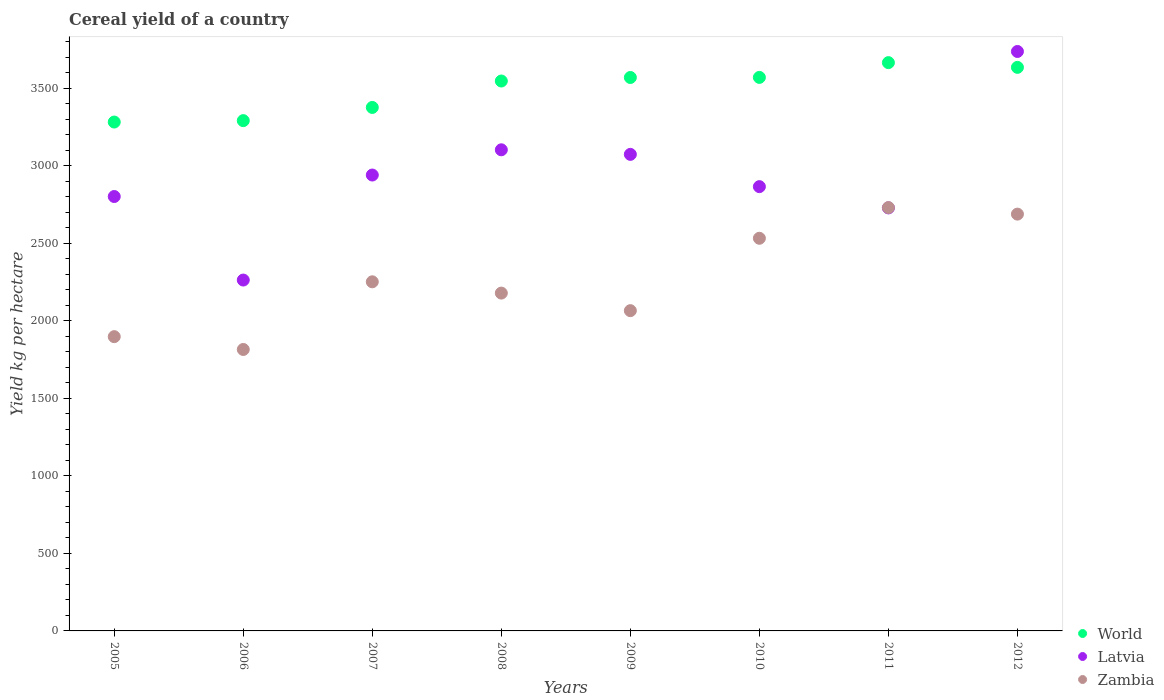How many different coloured dotlines are there?
Make the answer very short. 3. What is the total cereal yield in Latvia in 2010?
Give a very brief answer. 2866.68. Across all years, what is the maximum total cereal yield in Latvia?
Make the answer very short. 3738.81. Across all years, what is the minimum total cereal yield in Latvia?
Make the answer very short. 2263.97. In which year was the total cereal yield in World minimum?
Your answer should be very brief. 2005. What is the total total cereal yield in World in the graph?
Ensure brevity in your answer.  2.79e+04. What is the difference between the total cereal yield in Zambia in 2005 and that in 2009?
Offer a very short reply. -167.71. What is the difference between the total cereal yield in Latvia in 2008 and the total cereal yield in Zambia in 2010?
Your response must be concise. 570.87. What is the average total cereal yield in World per year?
Offer a very short reply. 3493.44. In the year 2010, what is the difference between the total cereal yield in World and total cereal yield in Latvia?
Your answer should be very brief. 704.85. In how many years, is the total cereal yield in World greater than 1500 kg per hectare?
Ensure brevity in your answer.  8. What is the ratio of the total cereal yield in World in 2008 to that in 2009?
Your answer should be very brief. 0.99. What is the difference between the highest and the second highest total cereal yield in Latvia?
Ensure brevity in your answer.  634.43. What is the difference between the highest and the lowest total cereal yield in Latvia?
Give a very brief answer. 1474.84. Does the total cereal yield in Latvia monotonically increase over the years?
Keep it short and to the point. No. Is the total cereal yield in Latvia strictly greater than the total cereal yield in World over the years?
Ensure brevity in your answer.  No. What is the difference between two consecutive major ticks on the Y-axis?
Offer a terse response. 500. Are the values on the major ticks of Y-axis written in scientific E-notation?
Give a very brief answer. No. Does the graph contain any zero values?
Your answer should be very brief. No. Where does the legend appear in the graph?
Give a very brief answer. Bottom right. How are the legend labels stacked?
Offer a terse response. Vertical. What is the title of the graph?
Offer a very short reply. Cereal yield of a country. What is the label or title of the X-axis?
Offer a very short reply. Years. What is the label or title of the Y-axis?
Your answer should be compact. Yield kg per hectare. What is the Yield kg per hectare in World in 2005?
Provide a succinct answer. 3283.52. What is the Yield kg per hectare of Latvia in 2005?
Your answer should be very brief. 2802.94. What is the Yield kg per hectare in Zambia in 2005?
Give a very brief answer. 1898.74. What is the Yield kg per hectare in World in 2006?
Make the answer very short. 3292.55. What is the Yield kg per hectare of Latvia in 2006?
Your answer should be very brief. 2263.97. What is the Yield kg per hectare in Zambia in 2006?
Offer a very short reply. 1815.98. What is the Yield kg per hectare of World in 2007?
Provide a succinct answer. 3377.69. What is the Yield kg per hectare of Latvia in 2007?
Offer a terse response. 2941.56. What is the Yield kg per hectare of Zambia in 2007?
Make the answer very short. 2252.64. What is the Yield kg per hectare in World in 2008?
Give a very brief answer. 3548.21. What is the Yield kg per hectare in Latvia in 2008?
Make the answer very short. 3104.37. What is the Yield kg per hectare in Zambia in 2008?
Make the answer very short. 2179.78. What is the Yield kg per hectare in World in 2009?
Offer a very short reply. 3570.96. What is the Yield kg per hectare in Latvia in 2009?
Provide a short and direct response. 3074.88. What is the Yield kg per hectare of Zambia in 2009?
Ensure brevity in your answer.  2066.44. What is the Yield kg per hectare in World in 2010?
Provide a short and direct response. 3571.53. What is the Yield kg per hectare in Latvia in 2010?
Provide a short and direct response. 2866.68. What is the Yield kg per hectare of Zambia in 2010?
Ensure brevity in your answer.  2533.5. What is the Yield kg per hectare in World in 2011?
Give a very brief answer. 3666.79. What is the Yield kg per hectare in Latvia in 2011?
Your answer should be compact. 2729.47. What is the Yield kg per hectare of Zambia in 2011?
Provide a short and direct response. 2731.43. What is the Yield kg per hectare in World in 2012?
Ensure brevity in your answer.  3636.3. What is the Yield kg per hectare of Latvia in 2012?
Ensure brevity in your answer.  3738.81. What is the Yield kg per hectare in Zambia in 2012?
Offer a very short reply. 2689.32. Across all years, what is the maximum Yield kg per hectare in World?
Your answer should be compact. 3666.79. Across all years, what is the maximum Yield kg per hectare in Latvia?
Offer a very short reply. 3738.81. Across all years, what is the maximum Yield kg per hectare in Zambia?
Make the answer very short. 2731.43. Across all years, what is the minimum Yield kg per hectare of World?
Ensure brevity in your answer.  3283.52. Across all years, what is the minimum Yield kg per hectare of Latvia?
Ensure brevity in your answer.  2263.97. Across all years, what is the minimum Yield kg per hectare in Zambia?
Ensure brevity in your answer.  1815.98. What is the total Yield kg per hectare in World in the graph?
Your answer should be compact. 2.79e+04. What is the total Yield kg per hectare of Latvia in the graph?
Your answer should be compact. 2.35e+04. What is the total Yield kg per hectare in Zambia in the graph?
Provide a short and direct response. 1.82e+04. What is the difference between the Yield kg per hectare of World in 2005 and that in 2006?
Provide a succinct answer. -9.04. What is the difference between the Yield kg per hectare in Latvia in 2005 and that in 2006?
Keep it short and to the point. 538.97. What is the difference between the Yield kg per hectare in Zambia in 2005 and that in 2006?
Provide a short and direct response. 82.76. What is the difference between the Yield kg per hectare in World in 2005 and that in 2007?
Your response must be concise. -94.18. What is the difference between the Yield kg per hectare of Latvia in 2005 and that in 2007?
Your response must be concise. -138.62. What is the difference between the Yield kg per hectare in Zambia in 2005 and that in 2007?
Offer a very short reply. -353.9. What is the difference between the Yield kg per hectare of World in 2005 and that in 2008?
Provide a short and direct response. -264.69. What is the difference between the Yield kg per hectare of Latvia in 2005 and that in 2008?
Keep it short and to the point. -301.43. What is the difference between the Yield kg per hectare in Zambia in 2005 and that in 2008?
Make the answer very short. -281.04. What is the difference between the Yield kg per hectare in World in 2005 and that in 2009?
Keep it short and to the point. -287.44. What is the difference between the Yield kg per hectare in Latvia in 2005 and that in 2009?
Offer a very short reply. -271.93. What is the difference between the Yield kg per hectare of Zambia in 2005 and that in 2009?
Make the answer very short. -167.71. What is the difference between the Yield kg per hectare of World in 2005 and that in 2010?
Provide a succinct answer. -288.02. What is the difference between the Yield kg per hectare of Latvia in 2005 and that in 2010?
Provide a short and direct response. -63.74. What is the difference between the Yield kg per hectare of Zambia in 2005 and that in 2010?
Give a very brief answer. -634.77. What is the difference between the Yield kg per hectare of World in 2005 and that in 2011?
Your answer should be compact. -383.27. What is the difference between the Yield kg per hectare of Latvia in 2005 and that in 2011?
Provide a short and direct response. 73.47. What is the difference between the Yield kg per hectare in Zambia in 2005 and that in 2011?
Your answer should be compact. -832.69. What is the difference between the Yield kg per hectare of World in 2005 and that in 2012?
Keep it short and to the point. -352.79. What is the difference between the Yield kg per hectare of Latvia in 2005 and that in 2012?
Ensure brevity in your answer.  -935.86. What is the difference between the Yield kg per hectare in Zambia in 2005 and that in 2012?
Keep it short and to the point. -790.58. What is the difference between the Yield kg per hectare in World in 2006 and that in 2007?
Offer a terse response. -85.14. What is the difference between the Yield kg per hectare of Latvia in 2006 and that in 2007?
Offer a terse response. -677.59. What is the difference between the Yield kg per hectare in Zambia in 2006 and that in 2007?
Ensure brevity in your answer.  -436.66. What is the difference between the Yield kg per hectare in World in 2006 and that in 2008?
Offer a very short reply. -255.66. What is the difference between the Yield kg per hectare of Latvia in 2006 and that in 2008?
Provide a succinct answer. -840.4. What is the difference between the Yield kg per hectare of Zambia in 2006 and that in 2008?
Keep it short and to the point. -363.8. What is the difference between the Yield kg per hectare in World in 2006 and that in 2009?
Provide a short and direct response. -278.41. What is the difference between the Yield kg per hectare in Latvia in 2006 and that in 2009?
Provide a short and direct response. -810.9. What is the difference between the Yield kg per hectare of Zambia in 2006 and that in 2009?
Give a very brief answer. -250.46. What is the difference between the Yield kg per hectare of World in 2006 and that in 2010?
Make the answer very short. -278.98. What is the difference between the Yield kg per hectare in Latvia in 2006 and that in 2010?
Offer a very short reply. -602.71. What is the difference between the Yield kg per hectare in Zambia in 2006 and that in 2010?
Provide a succinct answer. -717.52. What is the difference between the Yield kg per hectare of World in 2006 and that in 2011?
Offer a very short reply. -374.23. What is the difference between the Yield kg per hectare in Latvia in 2006 and that in 2011?
Ensure brevity in your answer.  -465.5. What is the difference between the Yield kg per hectare of Zambia in 2006 and that in 2011?
Provide a short and direct response. -915.45. What is the difference between the Yield kg per hectare of World in 2006 and that in 2012?
Give a very brief answer. -343.75. What is the difference between the Yield kg per hectare of Latvia in 2006 and that in 2012?
Offer a terse response. -1474.84. What is the difference between the Yield kg per hectare of Zambia in 2006 and that in 2012?
Provide a short and direct response. -873.34. What is the difference between the Yield kg per hectare in World in 2007 and that in 2008?
Offer a very short reply. -170.51. What is the difference between the Yield kg per hectare of Latvia in 2007 and that in 2008?
Offer a terse response. -162.81. What is the difference between the Yield kg per hectare of Zambia in 2007 and that in 2008?
Keep it short and to the point. 72.86. What is the difference between the Yield kg per hectare of World in 2007 and that in 2009?
Provide a short and direct response. -193.26. What is the difference between the Yield kg per hectare in Latvia in 2007 and that in 2009?
Your response must be concise. -133.31. What is the difference between the Yield kg per hectare of Zambia in 2007 and that in 2009?
Offer a very short reply. 186.2. What is the difference between the Yield kg per hectare in World in 2007 and that in 2010?
Your answer should be very brief. -193.84. What is the difference between the Yield kg per hectare in Latvia in 2007 and that in 2010?
Keep it short and to the point. 74.88. What is the difference between the Yield kg per hectare of Zambia in 2007 and that in 2010?
Your answer should be compact. -280.86. What is the difference between the Yield kg per hectare in World in 2007 and that in 2011?
Give a very brief answer. -289.09. What is the difference between the Yield kg per hectare in Latvia in 2007 and that in 2011?
Give a very brief answer. 212.09. What is the difference between the Yield kg per hectare in Zambia in 2007 and that in 2011?
Offer a very short reply. -478.79. What is the difference between the Yield kg per hectare of World in 2007 and that in 2012?
Your response must be concise. -258.61. What is the difference between the Yield kg per hectare of Latvia in 2007 and that in 2012?
Provide a succinct answer. -797.25. What is the difference between the Yield kg per hectare in Zambia in 2007 and that in 2012?
Give a very brief answer. -436.68. What is the difference between the Yield kg per hectare of World in 2008 and that in 2009?
Make the answer very short. -22.75. What is the difference between the Yield kg per hectare of Latvia in 2008 and that in 2009?
Your answer should be compact. 29.5. What is the difference between the Yield kg per hectare in Zambia in 2008 and that in 2009?
Your answer should be very brief. 113.34. What is the difference between the Yield kg per hectare in World in 2008 and that in 2010?
Your answer should be very brief. -23.33. What is the difference between the Yield kg per hectare of Latvia in 2008 and that in 2010?
Offer a very short reply. 237.69. What is the difference between the Yield kg per hectare in Zambia in 2008 and that in 2010?
Ensure brevity in your answer.  -353.72. What is the difference between the Yield kg per hectare of World in 2008 and that in 2011?
Offer a very short reply. -118.58. What is the difference between the Yield kg per hectare in Latvia in 2008 and that in 2011?
Give a very brief answer. 374.9. What is the difference between the Yield kg per hectare in Zambia in 2008 and that in 2011?
Provide a short and direct response. -551.65. What is the difference between the Yield kg per hectare in World in 2008 and that in 2012?
Make the answer very short. -88.1. What is the difference between the Yield kg per hectare in Latvia in 2008 and that in 2012?
Provide a succinct answer. -634.43. What is the difference between the Yield kg per hectare in Zambia in 2008 and that in 2012?
Offer a very short reply. -509.54. What is the difference between the Yield kg per hectare of World in 2009 and that in 2010?
Make the answer very short. -0.58. What is the difference between the Yield kg per hectare of Latvia in 2009 and that in 2010?
Offer a very short reply. 208.19. What is the difference between the Yield kg per hectare of Zambia in 2009 and that in 2010?
Give a very brief answer. -467.06. What is the difference between the Yield kg per hectare in World in 2009 and that in 2011?
Your answer should be very brief. -95.83. What is the difference between the Yield kg per hectare of Latvia in 2009 and that in 2011?
Provide a succinct answer. 345.4. What is the difference between the Yield kg per hectare of Zambia in 2009 and that in 2011?
Provide a succinct answer. -664.99. What is the difference between the Yield kg per hectare in World in 2009 and that in 2012?
Make the answer very short. -65.35. What is the difference between the Yield kg per hectare of Latvia in 2009 and that in 2012?
Your answer should be very brief. -663.93. What is the difference between the Yield kg per hectare in Zambia in 2009 and that in 2012?
Keep it short and to the point. -622.88. What is the difference between the Yield kg per hectare in World in 2010 and that in 2011?
Provide a short and direct response. -95.25. What is the difference between the Yield kg per hectare in Latvia in 2010 and that in 2011?
Your response must be concise. 137.21. What is the difference between the Yield kg per hectare of Zambia in 2010 and that in 2011?
Keep it short and to the point. -197.93. What is the difference between the Yield kg per hectare in World in 2010 and that in 2012?
Your response must be concise. -64.77. What is the difference between the Yield kg per hectare in Latvia in 2010 and that in 2012?
Make the answer very short. -872.13. What is the difference between the Yield kg per hectare in Zambia in 2010 and that in 2012?
Keep it short and to the point. -155.81. What is the difference between the Yield kg per hectare in World in 2011 and that in 2012?
Your response must be concise. 30.48. What is the difference between the Yield kg per hectare of Latvia in 2011 and that in 2012?
Ensure brevity in your answer.  -1009.33. What is the difference between the Yield kg per hectare of Zambia in 2011 and that in 2012?
Offer a terse response. 42.11. What is the difference between the Yield kg per hectare in World in 2005 and the Yield kg per hectare in Latvia in 2006?
Your answer should be compact. 1019.54. What is the difference between the Yield kg per hectare in World in 2005 and the Yield kg per hectare in Zambia in 2006?
Provide a short and direct response. 1467.54. What is the difference between the Yield kg per hectare in Latvia in 2005 and the Yield kg per hectare in Zambia in 2006?
Offer a very short reply. 986.96. What is the difference between the Yield kg per hectare of World in 2005 and the Yield kg per hectare of Latvia in 2007?
Ensure brevity in your answer.  341.95. What is the difference between the Yield kg per hectare of World in 2005 and the Yield kg per hectare of Zambia in 2007?
Give a very brief answer. 1030.88. What is the difference between the Yield kg per hectare in Latvia in 2005 and the Yield kg per hectare in Zambia in 2007?
Keep it short and to the point. 550.3. What is the difference between the Yield kg per hectare of World in 2005 and the Yield kg per hectare of Latvia in 2008?
Offer a very short reply. 179.14. What is the difference between the Yield kg per hectare in World in 2005 and the Yield kg per hectare in Zambia in 2008?
Your answer should be compact. 1103.73. What is the difference between the Yield kg per hectare of Latvia in 2005 and the Yield kg per hectare of Zambia in 2008?
Provide a succinct answer. 623.16. What is the difference between the Yield kg per hectare of World in 2005 and the Yield kg per hectare of Latvia in 2009?
Ensure brevity in your answer.  208.64. What is the difference between the Yield kg per hectare of World in 2005 and the Yield kg per hectare of Zambia in 2009?
Your answer should be compact. 1217.07. What is the difference between the Yield kg per hectare in Latvia in 2005 and the Yield kg per hectare in Zambia in 2009?
Your answer should be compact. 736.5. What is the difference between the Yield kg per hectare in World in 2005 and the Yield kg per hectare in Latvia in 2010?
Your answer should be compact. 416.83. What is the difference between the Yield kg per hectare of World in 2005 and the Yield kg per hectare of Zambia in 2010?
Make the answer very short. 750.01. What is the difference between the Yield kg per hectare in Latvia in 2005 and the Yield kg per hectare in Zambia in 2010?
Ensure brevity in your answer.  269.44. What is the difference between the Yield kg per hectare of World in 2005 and the Yield kg per hectare of Latvia in 2011?
Keep it short and to the point. 554.04. What is the difference between the Yield kg per hectare in World in 2005 and the Yield kg per hectare in Zambia in 2011?
Your response must be concise. 552.09. What is the difference between the Yield kg per hectare of Latvia in 2005 and the Yield kg per hectare of Zambia in 2011?
Provide a short and direct response. 71.51. What is the difference between the Yield kg per hectare of World in 2005 and the Yield kg per hectare of Latvia in 2012?
Your answer should be very brief. -455.29. What is the difference between the Yield kg per hectare of World in 2005 and the Yield kg per hectare of Zambia in 2012?
Make the answer very short. 594.2. What is the difference between the Yield kg per hectare in Latvia in 2005 and the Yield kg per hectare in Zambia in 2012?
Provide a short and direct response. 113.63. What is the difference between the Yield kg per hectare of World in 2006 and the Yield kg per hectare of Latvia in 2007?
Your answer should be very brief. 350.99. What is the difference between the Yield kg per hectare of World in 2006 and the Yield kg per hectare of Zambia in 2007?
Give a very brief answer. 1039.91. What is the difference between the Yield kg per hectare in Latvia in 2006 and the Yield kg per hectare in Zambia in 2007?
Your answer should be compact. 11.33. What is the difference between the Yield kg per hectare in World in 2006 and the Yield kg per hectare in Latvia in 2008?
Give a very brief answer. 188.18. What is the difference between the Yield kg per hectare in World in 2006 and the Yield kg per hectare in Zambia in 2008?
Provide a succinct answer. 1112.77. What is the difference between the Yield kg per hectare in Latvia in 2006 and the Yield kg per hectare in Zambia in 2008?
Provide a succinct answer. 84.19. What is the difference between the Yield kg per hectare in World in 2006 and the Yield kg per hectare in Latvia in 2009?
Your answer should be very brief. 217.68. What is the difference between the Yield kg per hectare of World in 2006 and the Yield kg per hectare of Zambia in 2009?
Make the answer very short. 1226.11. What is the difference between the Yield kg per hectare of Latvia in 2006 and the Yield kg per hectare of Zambia in 2009?
Offer a terse response. 197.53. What is the difference between the Yield kg per hectare in World in 2006 and the Yield kg per hectare in Latvia in 2010?
Ensure brevity in your answer.  425.87. What is the difference between the Yield kg per hectare in World in 2006 and the Yield kg per hectare in Zambia in 2010?
Make the answer very short. 759.05. What is the difference between the Yield kg per hectare of Latvia in 2006 and the Yield kg per hectare of Zambia in 2010?
Your answer should be compact. -269.53. What is the difference between the Yield kg per hectare in World in 2006 and the Yield kg per hectare in Latvia in 2011?
Keep it short and to the point. 563.08. What is the difference between the Yield kg per hectare of World in 2006 and the Yield kg per hectare of Zambia in 2011?
Give a very brief answer. 561.12. What is the difference between the Yield kg per hectare in Latvia in 2006 and the Yield kg per hectare in Zambia in 2011?
Provide a succinct answer. -467.46. What is the difference between the Yield kg per hectare of World in 2006 and the Yield kg per hectare of Latvia in 2012?
Offer a terse response. -446.26. What is the difference between the Yield kg per hectare in World in 2006 and the Yield kg per hectare in Zambia in 2012?
Your answer should be compact. 603.24. What is the difference between the Yield kg per hectare of Latvia in 2006 and the Yield kg per hectare of Zambia in 2012?
Your response must be concise. -425.35. What is the difference between the Yield kg per hectare in World in 2007 and the Yield kg per hectare in Latvia in 2008?
Provide a succinct answer. 273.32. What is the difference between the Yield kg per hectare in World in 2007 and the Yield kg per hectare in Zambia in 2008?
Your answer should be compact. 1197.91. What is the difference between the Yield kg per hectare of Latvia in 2007 and the Yield kg per hectare of Zambia in 2008?
Keep it short and to the point. 761.78. What is the difference between the Yield kg per hectare of World in 2007 and the Yield kg per hectare of Latvia in 2009?
Provide a short and direct response. 302.82. What is the difference between the Yield kg per hectare in World in 2007 and the Yield kg per hectare in Zambia in 2009?
Ensure brevity in your answer.  1311.25. What is the difference between the Yield kg per hectare in Latvia in 2007 and the Yield kg per hectare in Zambia in 2009?
Make the answer very short. 875.12. What is the difference between the Yield kg per hectare of World in 2007 and the Yield kg per hectare of Latvia in 2010?
Keep it short and to the point. 511.01. What is the difference between the Yield kg per hectare in World in 2007 and the Yield kg per hectare in Zambia in 2010?
Ensure brevity in your answer.  844.19. What is the difference between the Yield kg per hectare in Latvia in 2007 and the Yield kg per hectare in Zambia in 2010?
Provide a short and direct response. 408.06. What is the difference between the Yield kg per hectare of World in 2007 and the Yield kg per hectare of Latvia in 2011?
Make the answer very short. 648.22. What is the difference between the Yield kg per hectare in World in 2007 and the Yield kg per hectare in Zambia in 2011?
Offer a very short reply. 646.27. What is the difference between the Yield kg per hectare in Latvia in 2007 and the Yield kg per hectare in Zambia in 2011?
Offer a very short reply. 210.13. What is the difference between the Yield kg per hectare in World in 2007 and the Yield kg per hectare in Latvia in 2012?
Provide a succinct answer. -361.11. What is the difference between the Yield kg per hectare in World in 2007 and the Yield kg per hectare in Zambia in 2012?
Offer a terse response. 688.38. What is the difference between the Yield kg per hectare in Latvia in 2007 and the Yield kg per hectare in Zambia in 2012?
Give a very brief answer. 252.24. What is the difference between the Yield kg per hectare of World in 2008 and the Yield kg per hectare of Latvia in 2009?
Provide a succinct answer. 473.33. What is the difference between the Yield kg per hectare in World in 2008 and the Yield kg per hectare in Zambia in 2009?
Keep it short and to the point. 1481.77. What is the difference between the Yield kg per hectare in Latvia in 2008 and the Yield kg per hectare in Zambia in 2009?
Make the answer very short. 1037.93. What is the difference between the Yield kg per hectare in World in 2008 and the Yield kg per hectare in Latvia in 2010?
Give a very brief answer. 681.53. What is the difference between the Yield kg per hectare of World in 2008 and the Yield kg per hectare of Zambia in 2010?
Keep it short and to the point. 1014.71. What is the difference between the Yield kg per hectare in Latvia in 2008 and the Yield kg per hectare in Zambia in 2010?
Keep it short and to the point. 570.87. What is the difference between the Yield kg per hectare of World in 2008 and the Yield kg per hectare of Latvia in 2011?
Make the answer very short. 818.73. What is the difference between the Yield kg per hectare in World in 2008 and the Yield kg per hectare in Zambia in 2011?
Ensure brevity in your answer.  816.78. What is the difference between the Yield kg per hectare of Latvia in 2008 and the Yield kg per hectare of Zambia in 2011?
Provide a short and direct response. 372.94. What is the difference between the Yield kg per hectare of World in 2008 and the Yield kg per hectare of Latvia in 2012?
Provide a short and direct response. -190.6. What is the difference between the Yield kg per hectare of World in 2008 and the Yield kg per hectare of Zambia in 2012?
Your answer should be very brief. 858.89. What is the difference between the Yield kg per hectare in Latvia in 2008 and the Yield kg per hectare in Zambia in 2012?
Your response must be concise. 415.06. What is the difference between the Yield kg per hectare of World in 2009 and the Yield kg per hectare of Latvia in 2010?
Make the answer very short. 704.28. What is the difference between the Yield kg per hectare in World in 2009 and the Yield kg per hectare in Zambia in 2010?
Make the answer very short. 1037.46. What is the difference between the Yield kg per hectare in Latvia in 2009 and the Yield kg per hectare in Zambia in 2010?
Offer a very short reply. 541.37. What is the difference between the Yield kg per hectare of World in 2009 and the Yield kg per hectare of Latvia in 2011?
Keep it short and to the point. 841.48. What is the difference between the Yield kg per hectare of World in 2009 and the Yield kg per hectare of Zambia in 2011?
Ensure brevity in your answer.  839.53. What is the difference between the Yield kg per hectare in Latvia in 2009 and the Yield kg per hectare in Zambia in 2011?
Keep it short and to the point. 343.45. What is the difference between the Yield kg per hectare in World in 2009 and the Yield kg per hectare in Latvia in 2012?
Give a very brief answer. -167.85. What is the difference between the Yield kg per hectare of World in 2009 and the Yield kg per hectare of Zambia in 2012?
Provide a short and direct response. 881.64. What is the difference between the Yield kg per hectare in Latvia in 2009 and the Yield kg per hectare in Zambia in 2012?
Keep it short and to the point. 385.56. What is the difference between the Yield kg per hectare in World in 2010 and the Yield kg per hectare in Latvia in 2011?
Your answer should be compact. 842.06. What is the difference between the Yield kg per hectare of World in 2010 and the Yield kg per hectare of Zambia in 2011?
Your response must be concise. 840.11. What is the difference between the Yield kg per hectare in Latvia in 2010 and the Yield kg per hectare in Zambia in 2011?
Your answer should be very brief. 135.25. What is the difference between the Yield kg per hectare of World in 2010 and the Yield kg per hectare of Latvia in 2012?
Give a very brief answer. -167.27. What is the difference between the Yield kg per hectare in World in 2010 and the Yield kg per hectare in Zambia in 2012?
Offer a very short reply. 882.22. What is the difference between the Yield kg per hectare in Latvia in 2010 and the Yield kg per hectare in Zambia in 2012?
Provide a short and direct response. 177.36. What is the difference between the Yield kg per hectare in World in 2011 and the Yield kg per hectare in Latvia in 2012?
Make the answer very short. -72.02. What is the difference between the Yield kg per hectare of World in 2011 and the Yield kg per hectare of Zambia in 2012?
Offer a terse response. 977.47. What is the difference between the Yield kg per hectare in Latvia in 2011 and the Yield kg per hectare in Zambia in 2012?
Your answer should be compact. 40.16. What is the average Yield kg per hectare in World per year?
Make the answer very short. 3493.44. What is the average Yield kg per hectare of Latvia per year?
Ensure brevity in your answer.  2940.34. What is the average Yield kg per hectare of Zambia per year?
Provide a succinct answer. 2270.98. In the year 2005, what is the difference between the Yield kg per hectare in World and Yield kg per hectare in Latvia?
Make the answer very short. 480.57. In the year 2005, what is the difference between the Yield kg per hectare in World and Yield kg per hectare in Zambia?
Keep it short and to the point. 1384.78. In the year 2005, what is the difference between the Yield kg per hectare in Latvia and Yield kg per hectare in Zambia?
Keep it short and to the point. 904.21. In the year 2006, what is the difference between the Yield kg per hectare in World and Yield kg per hectare in Latvia?
Your response must be concise. 1028.58. In the year 2006, what is the difference between the Yield kg per hectare in World and Yield kg per hectare in Zambia?
Ensure brevity in your answer.  1476.57. In the year 2006, what is the difference between the Yield kg per hectare of Latvia and Yield kg per hectare of Zambia?
Your answer should be compact. 447.99. In the year 2007, what is the difference between the Yield kg per hectare in World and Yield kg per hectare in Latvia?
Your answer should be compact. 436.13. In the year 2007, what is the difference between the Yield kg per hectare in World and Yield kg per hectare in Zambia?
Provide a short and direct response. 1125.06. In the year 2007, what is the difference between the Yield kg per hectare in Latvia and Yield kg per hectare in Zambia?
Give a very brief answer. 688.92. In the year 2008, what is the difference between the Yield kg per hectare in World and Yield kg per hectare in Latvia?
Your response must be concise. 443.83. In the year 2008, what is the difference between the Yield kg per hectare of World and Yield kg per hectare of Zambia?
Offer a terse response. 1368.43. In the year 2008, what is the difference between the Yield kg per hectare of Latvia and Yield kg per hectare of Zambia?
Give a very brief answer. 924.59. In the year 2009, what is the difference between the Yield kg per hectare in World and Yield kg per hectare in Latvia?
Ensure brevity in your answer.  496.08. In the year 2009, what is the difference between the Yield kg per hectare in World and Yield kg per hectare in Zambia?
Your response must be concise. 1504.52. In the year 2009, what is the difference between the Yield kg per hectare of Latvia and Yield kg per hectare of Zambia?
Your response must be concise. 1008.43. In the year 2010, what is the difference between the Yield kg per hectare in World and Yield kg per hectare in Latvia?
Your answer should be very brief. 704.85. In the year 2010, what is the difference between the Yield kg per hectare in World and Yield kg per hectare in Zambia?
Provide a short and direct response. 1038.03. In the year 2010, what is the difference between the Yield kg per hectare in Latvia and Yield kg per hectare in Zambia?
Your answer should be very brief. 333.18. In the year 2011, what is the difference between the Yield kg per hectare in World and Yield kg per hectare in Latvia?
Provide a short and direct response. 937.31. In the year 2011, what is the difference between the Yield kg per hectare of World and Yield kg per hectare of Zambia?
Offer a very short reply. 935.36. In the year 2011, what is the difference between the Yield kg per hectare in Latvia and Yield kg per hectare in Zambia?
Provide a succinct answer. -1.96. In the year 2012, what is the difference between the Yield kg per hectare of World and Yield kg per hectare of Latvia?
Ensure brevity in your answer.  -102.5. In the year 2012, what is the difference between the Yield kg per hectare in World and Yield kg per hectare in Zambia?
Make the answer very short. 946.99. In the year 2012, what is the difference between the Yield kg per hectare in Latvia and Yield kg per hectare in Zambia?
Your answer should be very brief. 1049.49. What is the ratio of the Yield kg per hectare of World in 2005 to that in 2006?
Your response must be concise. 1. What is the ratio of the Yield kg per hectare in Latvia in 2005 to that in 2006?
Offer a terse response. 1.24. What is the ratio of the Yield kg per hectare in Zambia in 2005 to that in 2006?
Your answer should be compact. 1.05. What is the ratio of the Yield kg per hectare of World in 2005 to that in 2007?
Keep it short and to the point. 0.97. What is the ratio of the Yield kg per hectare in Latvia in 2005 to that in 2007?
Your response must be concise. 0.95. What is the ratio of the Yield kg per hectare of Zambia in 2005 to that in 2007?
Give a very brief answer. 0.84. What is the ratio of the Yield kg per hectare in World in 2005 to that in 2008?
Keep it short and to the point. 0.93. What is the ratio of the Yield kg per hectare in Latvia in 2005 to that in 2008?
Provide a short and direct response. 0.9. What is the ratio of the Yield kg per hectare of Zambia in 2005 to that in 2008?
Give a very brief answer. 0.87. What is the ratio of the Yield kg per hectare in World in 2005 to that in 2009?
Your answer should be very brief. 0.92. What is the ratio of the Yield kg per hectare of Latvia in 2005 to that in 2009?
Offer a terse response. 0.91. What is the ratio of the Yield kg per hectare of Zambia in 2005 to that in 2009?
Provide a short and direct response. 0.92. What is the ratio of the Yield kg per hectare of World in 2005 to that in 2010?
Offer a terse response. 0.92. What is the ratio of the Yield kg per hectare in Latvia in 2005 to that in 2010?
Provide a succinct answer. 0.98. What is the ratio of the Yield kg per hectare of Zambia in 2005 to that in 2010?
Ensure brevity in your answer.  0.75. What is the ratio of the Yield kg per hectare of World in 2005 to that in 2011?
Provide a succinct answer. 0.9. What is the ratio of the Yield kg per hectare of Latvia in 2005 to that in 2011?
Give a very brief answer. 1.03. What is the ratio of the Yield kg per hectare in Zambia in 2005 to that in 2011?
Provide a succinct answer. 0.7. What is the ratio of the Yield kg per hectare in World in 2005 to that in 2012?
Make the answer very short. 0.9. What is the ratio of the Yield kg per hectare in Latvia in 2005 to that in 2012?
Your answer should be compact. 0.75. What is the ratio of the Yield kg per hectare of Zambia in 2005 to that in 2012?
Offer a terse response. 0.71. What is the ratio of the Yield kg per hectare in World in 2006 to that in 2007?
Offer a very short reply. 0.97. What is the ratio of the Yield kg per hectare of Latvia in 2006 to that in 2007?
Provide a succinct answer. 0.77. What is the ratio of the Yield kg per hectare in Zambia in 2006 to that in 2007?
Provide a succinct answer. 0.81. What is the ratio of the Yield kg per hectare of World in 2006 to that in 2008?
Give a very brief answer. 0.93. What is the ratio of the Yield kg per hectare in Latvia in 2006 to that in 2008?
Your answer should be very brief. 0.73. What is the ratio of the Yield kg per hectare of Zambia in 2006 to that in 2008?
Keep it short and to the point. 0.83. What is the ratio of the Yield kg per hectare of World in 2006 to that in 2009?
Your response must be concise. 0.92. What is the ratio of the Yield kg per hectare in Latvia in 2006 to that in 2009?
Offer a terse response. 0.74. What is the ratio of the Yield kg per hectare of Zambia in 2006 to that in 2009?
Your answer should be compact. 0.88. What is the ratio of the Yield kg per hectare in World in 2006 to that in 2010?
Ensure brevity in your answer.  0.92. What is the ratio of the Yield kg per hectare in Latvia in 2006 to that in 2010?
Keep it short and to the point. 0.79. What is the ratio of the Yield kg per hectare in Zambia in 2006 to that in 2010?
Offer a very short reply. 0.72. What is the ratio of the Yield kg per hectare in World in 2006 to that in 2011?
Provide a succinct answer. 0.9. What is the ratio of the Yield kg per hectare in Latvia in 2006 to that in 2011?
Ensure brevity in your answer.  0.83. What is the ratio of the Yield kg per hectare in Zambia in 2006 to that in 2011?
Keep it short and to the point. 0.66. What is the ratio of the Yield kg per hectare of World in 2006 to that in 2012?
Make the answer very short. 0.91. What is the ratio of the Yield kg per hectare in Latvia in 2006 to that in 2012?
Make the answer very short. 0.61. What is the ratio of the Yield kg per hectare in Zambia in 2006 to that in 2012?
Ensure brevity in your answer.  0.68. What is the ratio of the Yield kg per hectare of World in 2007 to that in 2008?
Provide a short and direct response. 0.95. What is the ratio of the Yield kg per hectare of Latvia in 2007 to that in 2008?
Your response must be concise. 0.95. What is the ratio of the Yield kg per hectare in Zambia in 2007 to that in 2008?
Provide a short and direct response. 1.03. What is the ratio of the Yield kg per hectare in World in 2007 to that in 2009?
Provide a succinct answer. 0.95. What is the ratio of the Yield kg per hectare in Latvia in 2007 to that in 2009?
Provide a succinct answer. 0.96. What is the ratio of the Yield kg per hectare in Zambia in 2007 to that in 2009?
Offer a very short reply. 1.09. What is the ratio of the Yield kg per hectare of World in 2007 to that in 2010?
Make the answer very short. 0.95. What is the ratio of the Yield kg per hectare in Latvia in 2007 to that in 2010?
Offer a very short reply. 1.03. What is the ratio of the Yield kg per hectare of Zambia in 2007 to that in 2010?
Offer a very short reply. 0.89. What is the ratio of the Yield kg per hectare of World in 2007 to that in 2011?
Make the answer very short. 0.92. What is the ratio of the Yield kg per hectare of Latvia in 2007 to that in 2011?
Provide a short and direct response. 1.08. What is the ratio of the Yield kg per hectare of Zambia in 2007 to that in 2011?
Make the answer very short. 0.82. What is the ratio of the Yield kg per hectare of World in 2007 to that in 2012?
Your answer should be very brief. 0.93. What is the ratio of the Yield kg per hectare of Latvia in 2007 to that in 2012?
Your answer should be very brief. 0.79. What is the ratio of the Yield kg per hectare of Zambia in 2007 to that in 2012?
Your answer should be very brief. 0.84. What is the ratio of the Yield kg per hectare of World in 2008 to that in 2009?
Offer a terse response. 0.99. What is the ratio of the Yield kg per hectare of Latvia in 2008 to that in 2009?
Ensure brevity in your answer.  1.01. What is the ratio of the Yield kg per hectare in Zambia in 2008 to that in 2009?
Your answer should be very brief. 1.05. What is the ratio of the Yield kg per hectare in Latvia in 2008 to that in 2010?
Offer a very short reply. 1.08. What is the ratio of the Yield kg per hectare in Zambia in 2008 to that in 2010?
Offer a very short reply. 0.86. What is the ratio of the Yield kg per hectare of World in 2008 to that in 2011?
Ensure brevity in your answer.  0.97. What is the ratio of the Yield kg per hectare of Latvia in 2008 to that in 2011?
Your answer should be compact. 1.14. What is the ratio of the Yield kg per hectare of Zambia in 2008 to that in 2011?
Make the answer very short. 0.8. What is the ratio of the Yield kg per hectare of World in 2008 to that in 2012?
Offer a terse response. 0.98. What is the ratio of the Yield kg per hectare of Latvia in 2008 to that in 2012?
Your answer should be compact. 0.83. What is the ratio of the Yield kg per hectare of Zambia in 2008 to that in 2012?
Keep it short and to the point. 0.81. What is the ratio of the Yield kg per hectare in Latvia in 2009 to that in 2010?
Provide a succinct answer. 1.07. What is the ratio of the Yield kg per hectare of Zambia in 2009 to that in 2010?
Keep it short and to the point. 0.82. What is the ratio of the Yield kg per hectare in World in 2009 to that in 2011?
Your response must be concise. 0.97. What is the ratio of the Yield kg per hectare of Latvia in 2009 to that in 2011?
Your answer should be very brief. 1.13. What is the ratio of the Yield kg per hectare of Zambia in 2009 to that in 2011?
Your answer should be compact. 0.76. What is the ratio of the Yield kg per hectare of World in 2009 to that in 2012?
Your response must be concise. 0.98. What is the ratio of the Yield kg per hectare in Latvia in 2009 to that in 2012?
Your response must be concise. 0.82. What is the ratio of the Yield kg per hectare in Zambia in 2009 to that in 2012?
Your response must be concise. 0.77. What is the ratio of the Yield kg per hectare of World in 2010 to that in 2011?
Offer a very short reply. 0.97. What is the ratio of the Yield kg per hectare of Latvia in 2010 to that in 2011?
Your answer should be very brief. 1.05. What is the ratio of the Yield kg per hectare in Zambia in 2010 to that in 2011?
Provide a short and direct response. 0.93. What is the ratio of the Yield kg per hectare of World in 2010 to that in 2012?
Provide a succinct answer. 0.98. What is the ratio of the Yield kg per hectare of Latvia in 2010 to that in 2012?
Your response must be concise. 0.77. What is the ratio of the Yield kg per hectare of Zambia in 2010 to that in 2012?
Your answer should be very brief. 0.94. What is the ratio of the Yield kg per hectare of World in 2011 to that in 2012?
Your answer should be compact. 1.01. What is the ratio of the Yield kg per hectare in Latvia in 2011 to that in 2012?
Provide a succinct answer. 0.73. What is the ratio of the Yield kg per hectare in Zambia in 2011 to that in 2012?
Your response must be concise. 1.02. What is the difference between the highest and the second highest Yield kg per hectare of World?
Provide a succinct answer. 30.48. What is the difference between the highest and the second highest Yield kg per hectare of Latvia?
Offer a terse response. 634.43. What is the difference between the highest and the second highest Yield kg per hectare of Zambia?
Keep it short and to the point. 42.11. What is the difference between the highest and the lowest Yield kg per hectare in World?
Give a very brief answer. 383.27. What is the difference between the highest and the lowest Yield kg per hectare in Latvia?
Offer a very short reply. 1474.84. What is the difference between the highest and the lowest Yield kg per hectare in Zambia?
Ensure brevity in your answer.  915.45. 